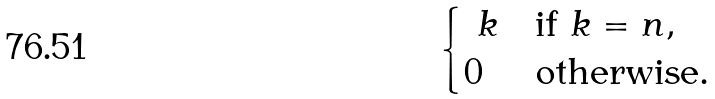<formula> <loc_0><loc_0><loc_500><loc_500>\begin{cases} \ k & \text {if $k=n$} , \\ 0 & \text {otherwise} . \end{cases}</formula> 